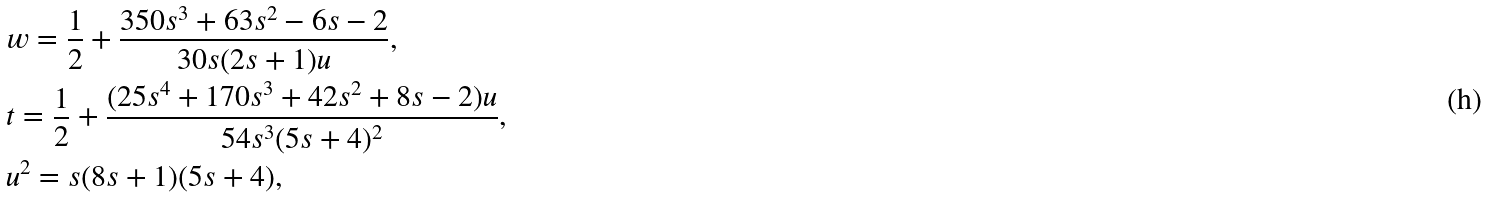<formula> <loc_0><loc_0><loc_500><loc_500>& w = \frac { 1 } { 2 } + \frac { 3 5 0 s ^ { 3 } + 6 3 s ^ { 2 } - 6 s - 2 } { 3 0 s ( 2 s + 1 ) u } , \\ & t = \frac { 1 } { 2 } + \frac { ( 2 5 s ^ { 4 } + 1 7 0 s ^ { 3 } + 4 2 s ^ { 2 } + 8 s - 2 ) u } { 5 4 s ^ { 3 } ( 5 s + 4 ) ^ { 2 } } , \\ & u ^ { 2 } = s ( 8 s + 1 ) ( 5 s + 4 ) ,</formula> 